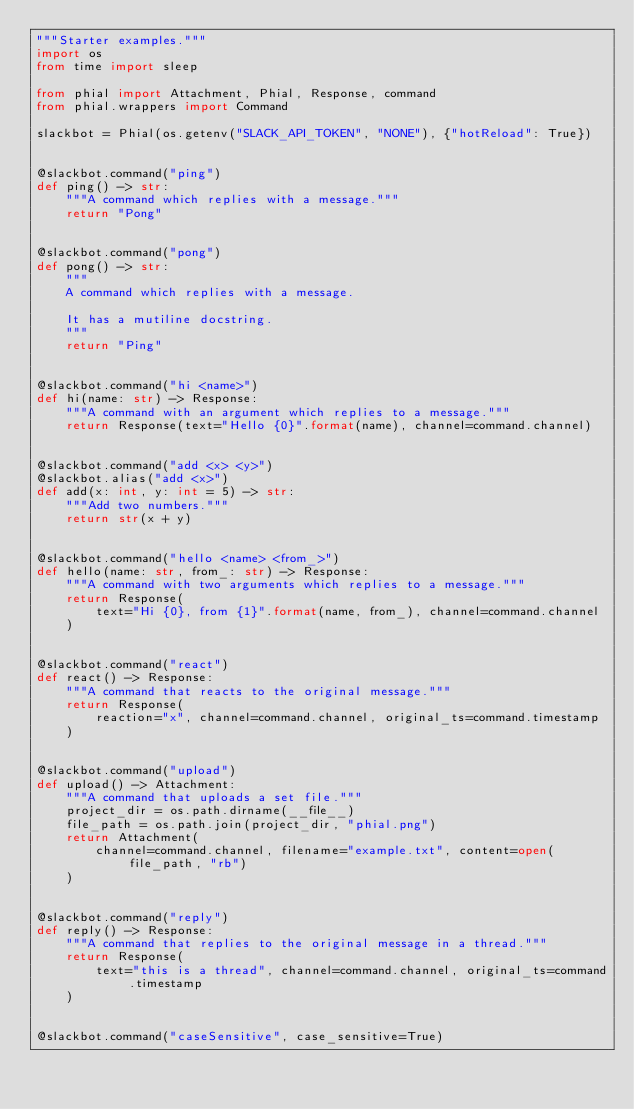<code> <loc_0><loc_0><loc_500><loc_500><_Python_>"""Starter examples."""
import os
from time import sleep

from phial import Attachment, Phial, Response, command
from phial.wrappers import Command

slackbot = Phial(os.getenv("SLACK_API_TOKEN", "NONE"), {"hotReload": True})


@slackbot.command("ping")
def ping() -> str:
    """A command which replies with a message."""
    return "Pong"


@slackbot.command("pong")
def pong() -> str:
    """
    A command which replies with a message.

    It has a mutiline docstring.
    """
    return "Ping"


@slackbot.command("hi <name>")
def hi(name: str) -> Response:
    """A command with an argument which replies to a message."""
    return Response(text="Hello {0}".format(name), channel=command.channel)


@slackbot.command("add <x> <y>")
@slackbot.alias("add <x>")
def add(x: int, y: int = 5) -> str:
    """Add two numbers."""
    return str(x + y)


@slackbot.command("hello <name> <from_>")
def hello(name: str, from_: str) -> Response:
    """A command with two arguments which replies to a message."""
    return Response(
        text="Hi {0}, from {1}".format(name, from_), channel=command.channel
    )


@slackbot.command("react")
def react() -> Response:
    """A command that reacts to the original message."""
    return Response(
        reaction="x", channel=command.channel, original_ts=command.timestamp
    )


@slackbot.command("upload")
def upload() -> Attachment:
    """A command that uploads a set file."""
    project_dir = os.path.dirname(__file__)
    file_path = os.path.join(project_dir, "phial.png")
    return Attachment(
        channel=command.channel, filename="example.txt", content=open(file_path, "rb")
    )


@slackbot.command("reply")
def reply() -> Response:
    """A command that replies to the original message in a thread."""
    return Response(
        text="this is a thread", channel=command.channel, original_ts=command.timestamp
    )


@slackbot.command("caseSensitive", case_sensitive=True)</code> 